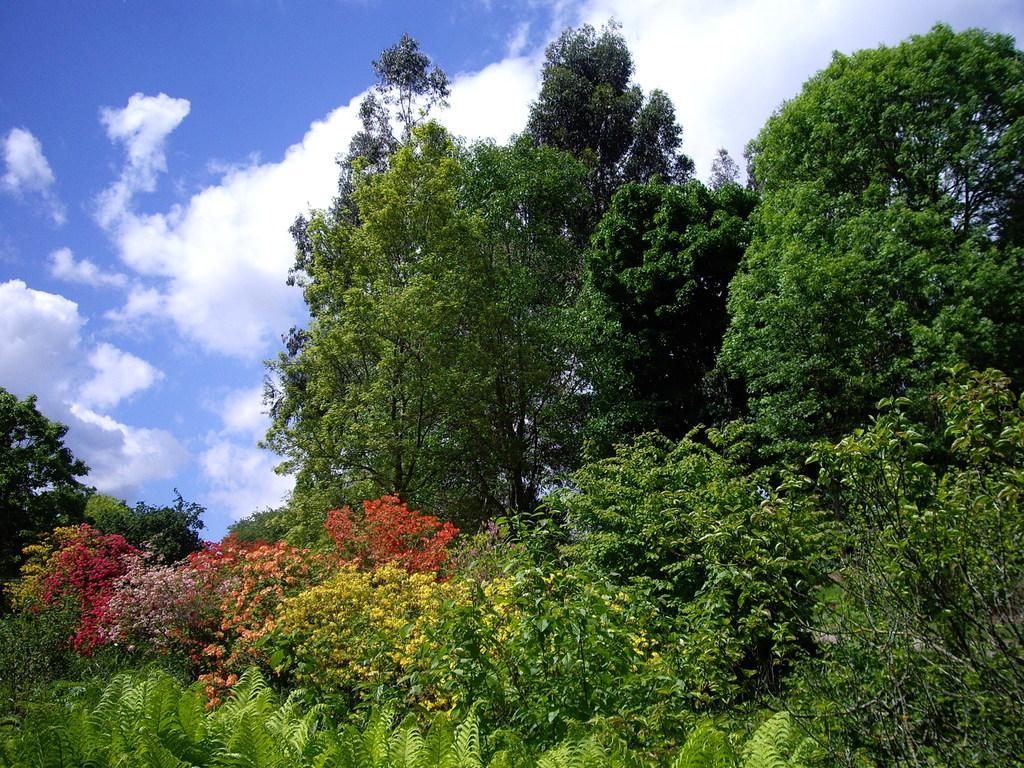How would you summarize this image in a sentence or two? In this picture we can see many trees. At the bottom we can see plants and grass. On the left we can see flowers on the plant. At the top we can see sky and clouds. 